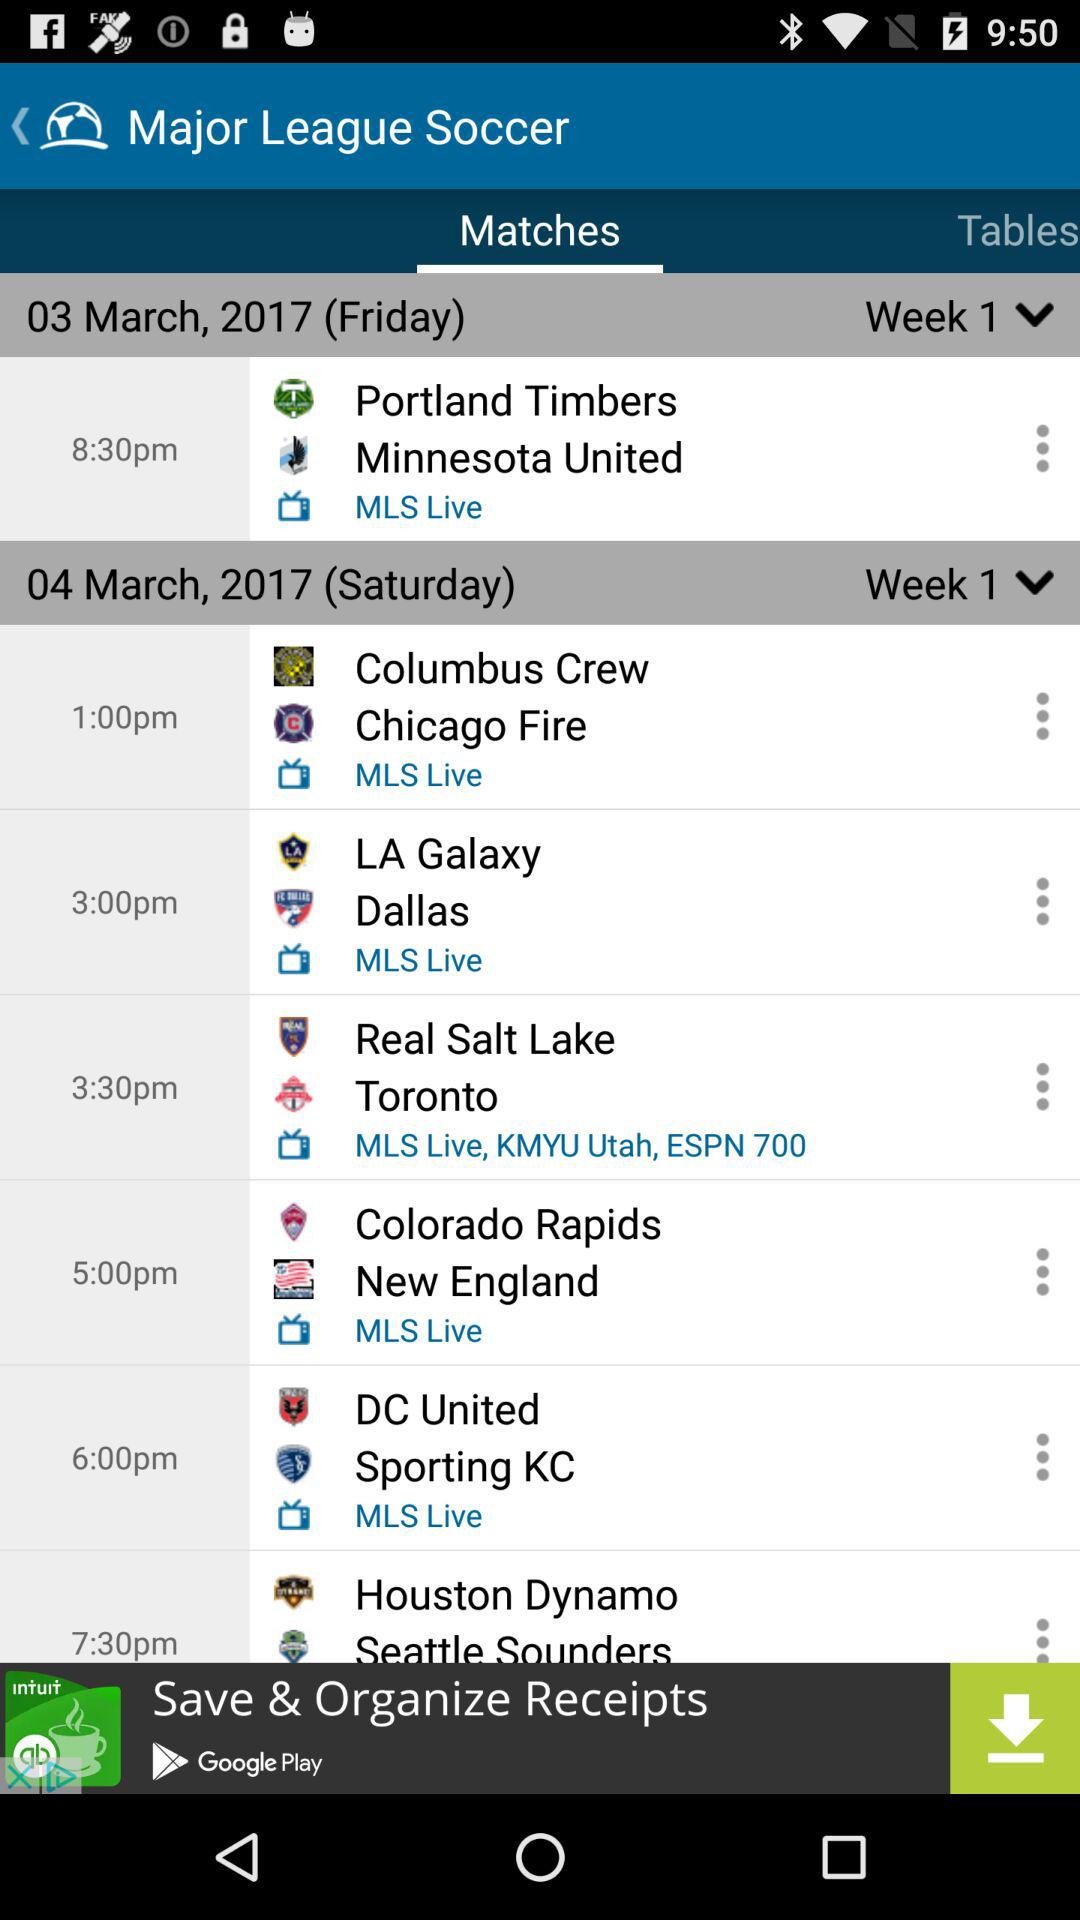When is the Portland Timbers vs. Minnesota United match? The match starts at 8:30 pm. 